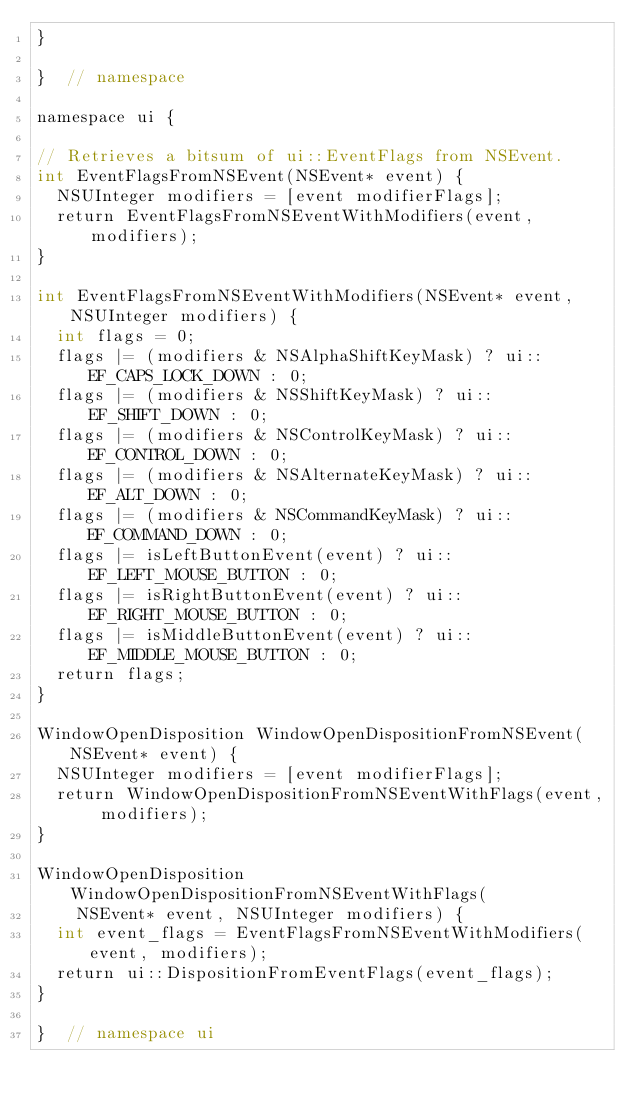<code> <loc_0><loc_0><loc_500><loc_500><_ObjectiveC_>}

}  // namespace

namespace ui {

// Retrieves a bitsum of ui::EventFlags from NSEvent.
int EventFlagsFromNSEvent(NSEvent* event) {
  NSUInteger modifiers = [event modifierFlags];
  return EventFlagsFromNSEventWithModifiers(event, modifiers);
}

int EventFlagsFromNSEventWithModifiers(NSEvent* event, NSUInteger modifiers) {
  int flags = 0;
  flags |= (modifiers & NSAlphaShiftKeyMask) ? ui::EF_CAPS_LOCK_DOWN : 0;
  flags |= (modifiers & NSShiftKeyMask) ? ui::EF_SHIFT_DOWN : 0;
  flags |= (modifiers & NSControlKeyMask) ? ui::EF_CONTROL_DOWN : 0;
  flags |= (modifiers & NSAlternateKeyMask) ? ui::EF_ALT_DOWN : 0;
  flags |= (modifiers & NSCommandKeyMask) ? ui::EF_COMMAND_DOWN : 0;
  flags |= isLeftButtonEvent(event) ? ui::EF_LEFT_MOUSE_BUTTON : 0;
  flags |= isRightButtonEvent(event) ? ui::EF_RIGHT_MOUSE_BUTTON : 0;
  flags |= isMiddleButtonEvent(event) ? ui::EF_MIDDLE_MOUSE_BUTTON : 0;
  return flags;
}

WindowOpenDisposition WindowOpenDispositionFromNSEvent(NSEvent* event) {
  NSUInteger modifiers = [event modifierFlags];
  return WindowOpenDispositionFromNSEventWithFlags(event, modifiers);
}

WindowOpenDisposition WindowOpenDispositionFromNSEventWithFlags(
    NSEvent* event, NSUInteger modifiers) {
  int event_flags = EventFlagsFromNSEventWithModifiers(event, modifiers);
  return ui::DispositionFromEventFlags(event_flags);
}

}  // namespace ui
</code> 